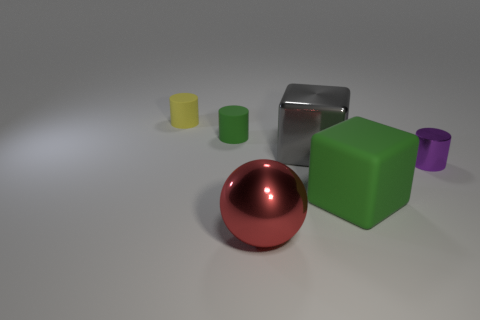Is the number of large balls that are on the right side of the small purple object less than the number of metallic things behind the big red metallic sphere? Upon reviewing the image, I can confirm that there is only one large ball on the right side of the small purple object, while there are two metallic objects behind the red metallic sphere. So, the answer is yes, the number of large balls is less than the number of metallic things in the stated positions. 